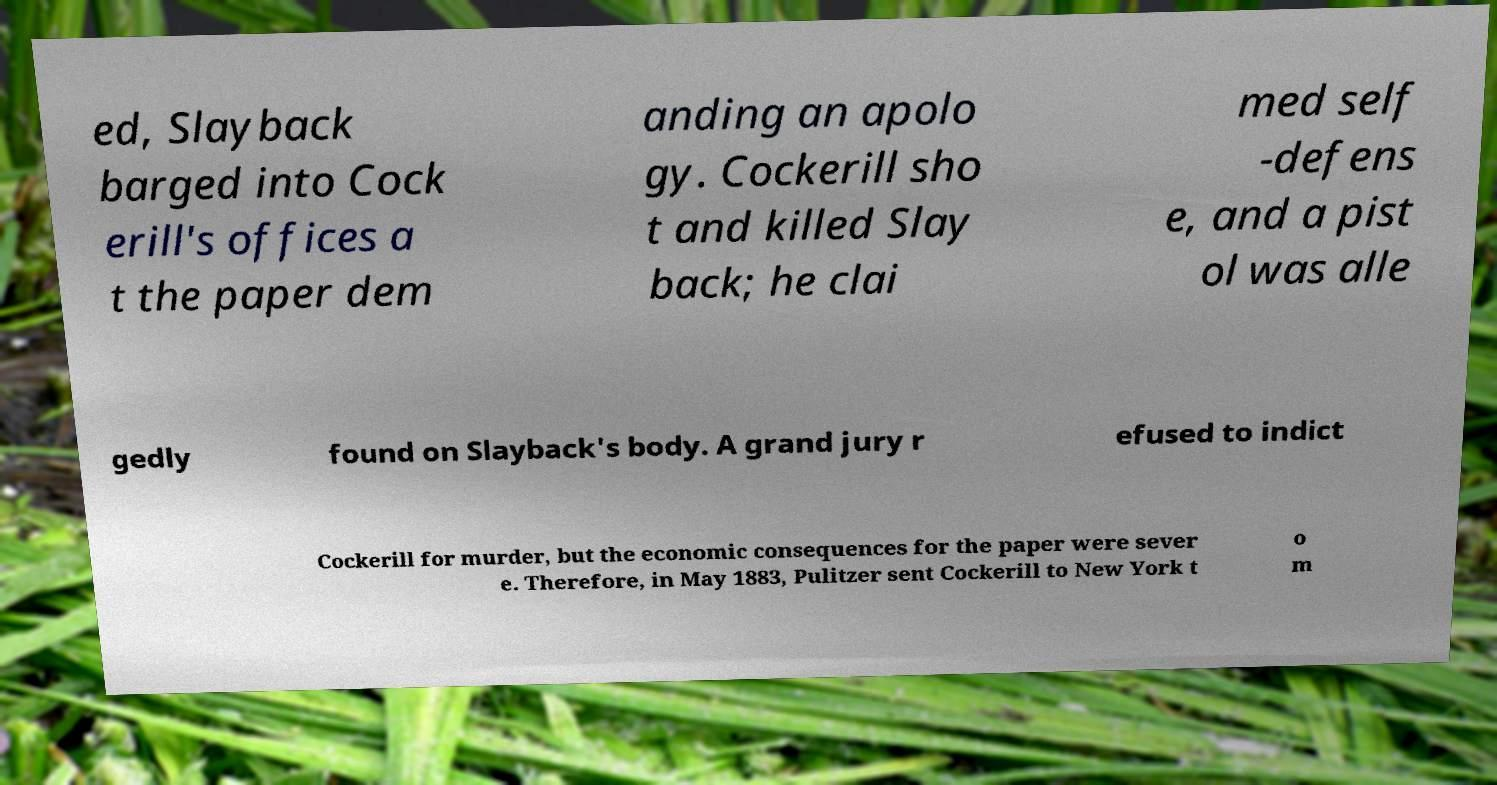Could you extract and type out the text from this image? ed, Slayback barged into Cock erill's offices a t the paper dem anding an apolo gy. Cockerill sho t and killed Slay back; he clai med self -defens e, and a pist ol was alle gedly found on Slayback's body. A grand jury r efused to indict Cockerill for murder, but the economic consequences for the paper were sever e. Therefore, in May 1883, Pulitzer sent Cockerill to New York t o m 